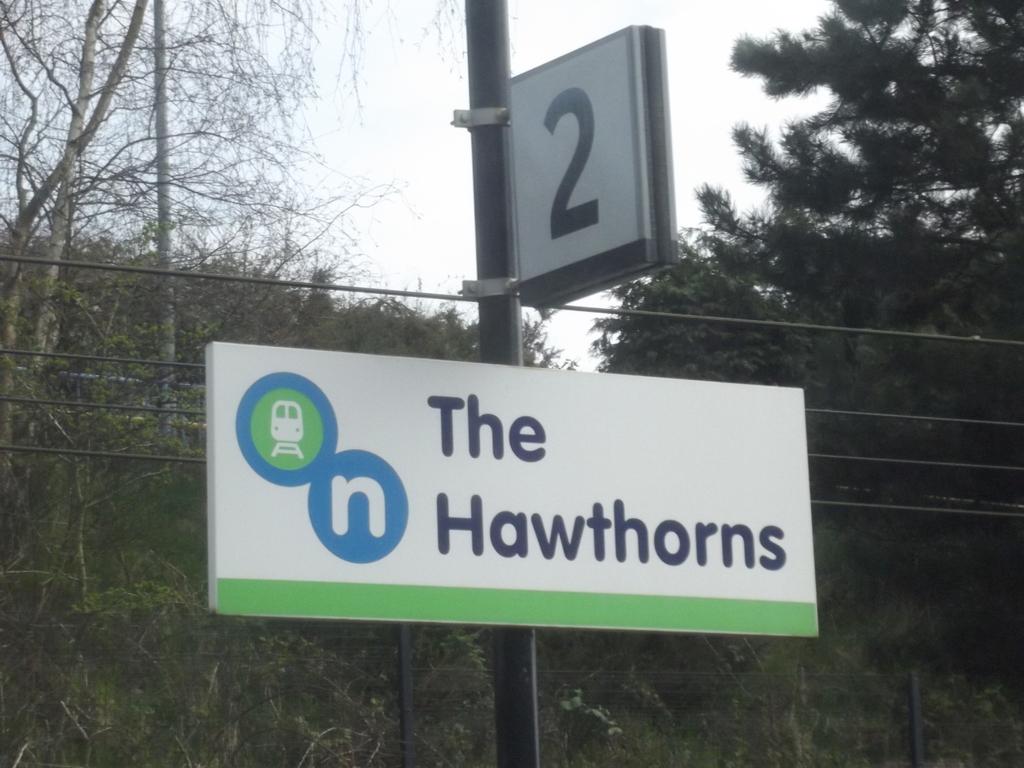Where does the sign say the train is going?
Make the answer very short. The hawthorns. 